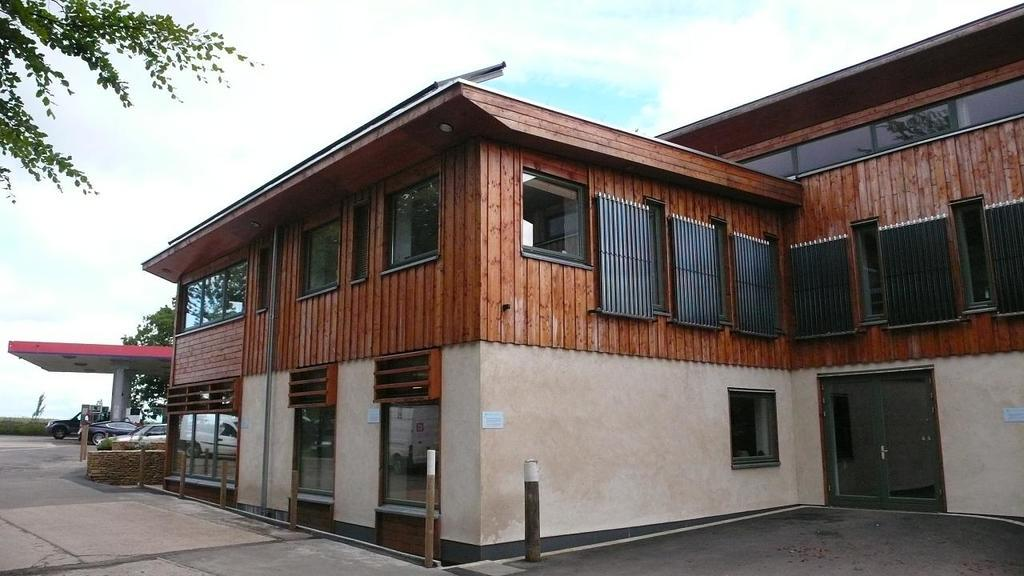What type of structure is present in the image? There is a building with windows in the image. What is located to the left of the building? There is a shed to the left of the building. What can be seen near the shed? There are vehicles near the shed. What is visible in the background of the image? There are trees and the sky in the background of the image. How many eggs are visible on the roof of the building in the image? There are no eggs visible on the roof of the building in the image. 